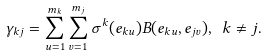Convert formula to latex. <formula><loc_0><loc_0><loc_500><loc_500>\gamma _ { k j } = \sum _ { u = 1 } ^ { m _ { k } } \sum _ { v = 1 } ^ { m _ { j } } \sigma ^ { k } ( e _ { k u } ) B ( e _ { k u } , e _ { j v } ) , \ k \ne j .</formula> 